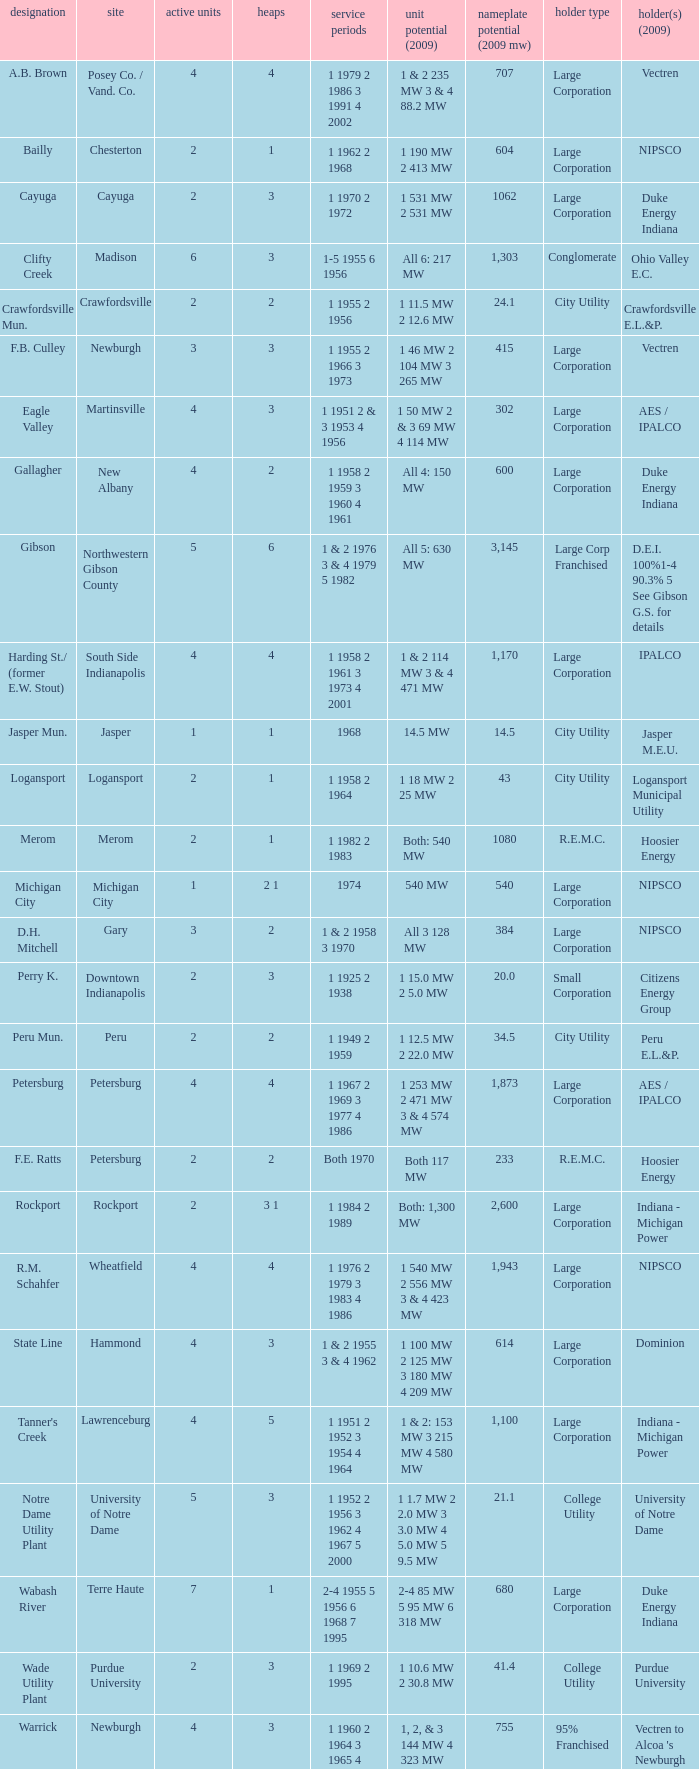Name the owners 2009 for south side indianapolis IPALCO. 